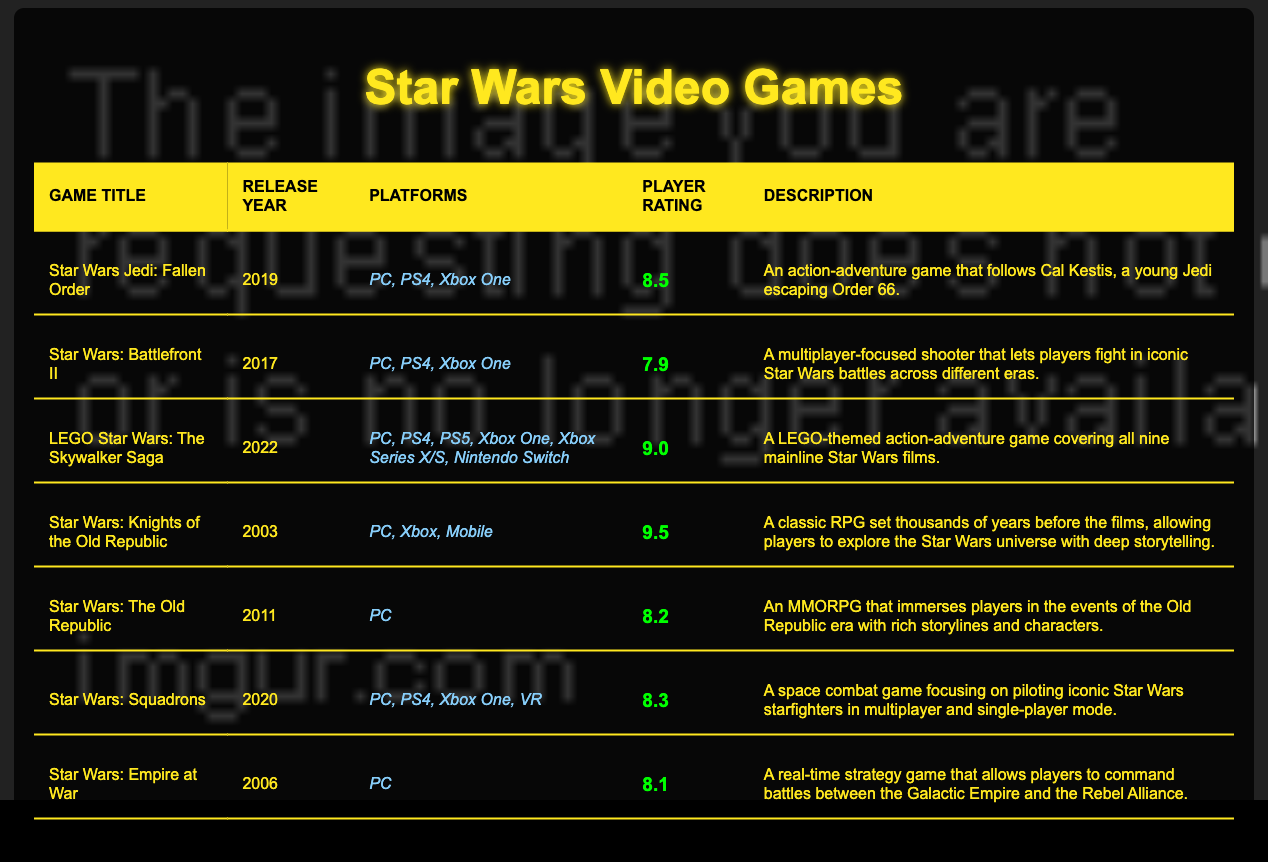What is the highest player rating among the listed games? The highest player rating can be found by looking through the player rating column in the table. The game "Star Wars: Knights of the Old Republic" has the highest rating with 9.5.
Answer: 9.5 Which game was released most recently? To find the most recent game, we check the release year column. The game "LEGO Star Wars: The Skywalker Saga" was released in 2022, which is the latest year listed.
Answer: LEGO Star Wars: The Skywalker Saga How many games have a player rating above 8.0? We can look at the player rating column and count how many ratings are greater than 8.0. The games "LEGO Star Wars: The Skywalker Saga," "Star Wars: Knights of the Old Republic," "Star Wars Jedi: Fallen Order," "Star Wars: Squadrons," and "Star Wars: The Old Republic" have ratings above 8.0, totaling 5 games.
Answer: 5 What platforms is "Star Wars: Battlefront II" available on? The platforms for "Star Wars: Battlefront II" can be found by checking the platforms column for that specific game. It is available on PC, PS4, and Xbox One.
Answer: PC, PS4, Xbox One Is "Star Wars: Empire at War" rated higher than "Star Wars: The Old Republic"? To answer this, we compare the player ratings of both games. "Star Wars: Empire at War" has a rating of 8.1, while "Star Wars: The Old Republic" has a rating of 8.2. Since 8.1 is less than 8.2, the statement is false.
Answer: No Which game has the most platforms listed? We can examine the platforms column for each game and count the number of platforms listed. "LEGO Star Wars: The Skywalker Saga" has the most platforms, with a total of 6 (PC, PS4, PS5, Xbox One, Xbox Series X/S, Nintendo Switch).
Answer: LEGO Star Wars: The Skywalker Saga What is the average player rating of all the games listed? To find the average, we add all player ratings together: 8.5 + 7.9 + 9.0 + 9.5 + 8.2 + 8.3 + 8.1 = 59.5. There are 7 games, so the average is 59.5 / 7 = 8.5.
Answer: 8.5 Which game has a rating closest to 8.0? We examine the player ratings and calculate the absolute difference from 8.0 for each game. "Star Wars: Battlefront II" with a rating of 7.9 is just 0.1 away from 8.0, making it the closest game to that rating.
Answer: Star Wars: Battlefront II Has there ever been a game that achieves a rating of 10.0? By scanning the player rating data, we can confirm that none of the listed games have a rating of 10.0; the highest rating is 9.5. Therefore, the statement is false.
Answer: No 